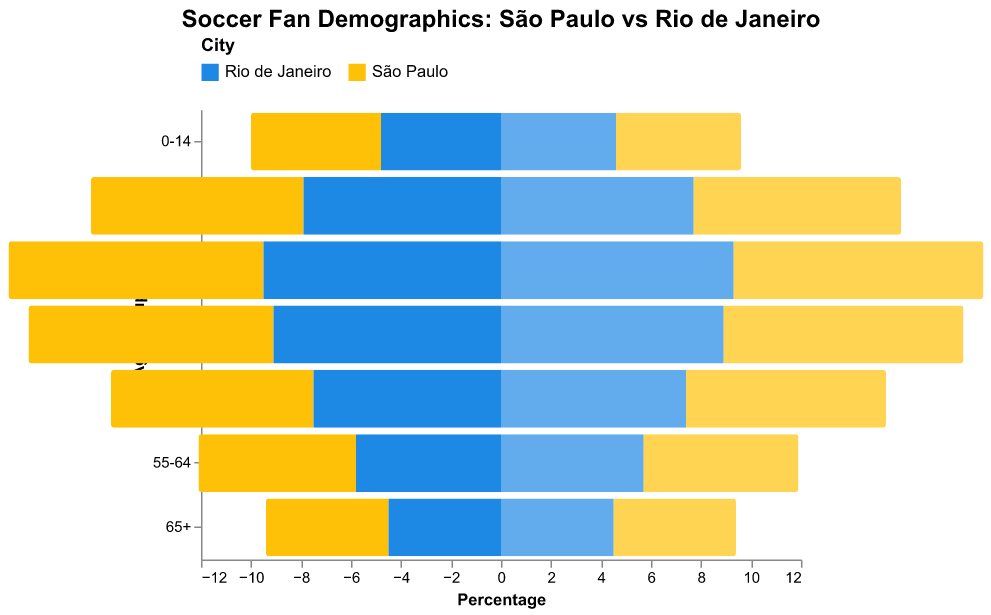Which age group has the highest percentage of male soccer fans in São Paulo? In São Paulo, the age group with the highest percentage of male soccer fans is found by looking at the São Paulo Males column. The 25-34 age group has the highest percentage at 10.2%.
Answer: 25-34 What is the sum of the percentages for female soccer fans aged 15-24 in both cities? Add the percentages of female soccer fans aged 15-24 in São Paulo and Rio de Janeiro. For São Paulo, it is 8.3%, and for Rio de Janeiro, it is 7.7%. The total is 8.3 + 7.7 = 16%.
Answer: 16% How do the percentages of male soccer fans aged 35-44 compare between São Paulo and Rio de Janeiro? For São Paulo, male soccer fans aged 35-44 form 9.8% of the population, whereas in Rio de Janeiro, they form 9.1%. Thus, São Paulo has a higher percentage.
Answer: São Paulo Which city has a higher percentage of female soccer fans overall? Add the percentages of female soccer fans in each age group for both cities and compare. São Paulo: 5.0 + 8.3 + 10.0 + 9.6 + 8.0 + 6.2 + 4.9 = 52%. Rio de Janeiro: 4.6 + 7.7 + 9.3 + 8.9 + 7.4 + 5.7 + 4.5 = 48.1%. São Paulo has a higher percentage.
Answer: São Paulo What is the difference in the percentage of male soccer fans aged 55-64 between São Paulo and Rio de Janeiro? Subtract the percentage of male soccer fans aged 55-64 in Rio de Janeiro from those in São Paulo. São Paulo is 6.3%, and Rio de Janeiro is 5.8%. The difference is 6.3 – 5.8 = 0.5%.
Answer: 0.5% What trend can be observed for the percentage of soccer fans over 65 years in both cities? The percentages of soccer fans over 65 years in both cities decrease to 4.9% for São Paulo and 4.5% for Rio de Janeiro, indicating an overall lower percentage of older soccer fans.
Answer: Decreasing trend In the 25-34 age group, who has a higher percentage of fans: São Paulo males or Rio de Janeiro males? Compare the data for São Paulo males and Rio de Janeiro males in the 25-34 age group. São Paulo males are at 10.2%, while Rio de Janeiro males are at 9.5%.
Answer: São Paulo males 